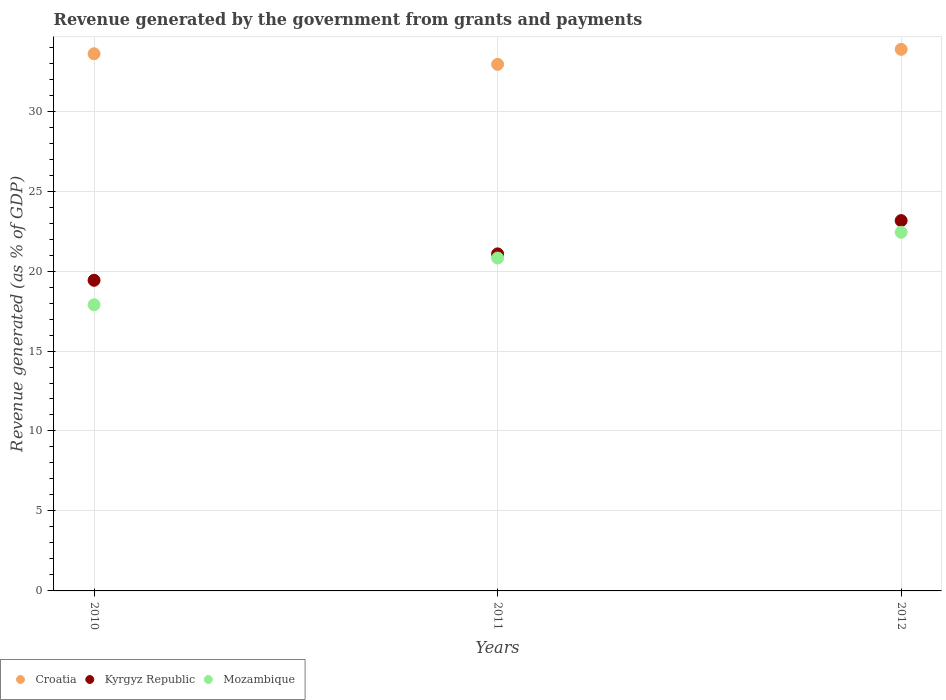How many different coloured dotlines are there?
Your answer should be compact. 3. What is the revenue generated by the government in Mozambique in 2010?
Make the answer very short. 17.89. Across all years, what is the maximum revenue generated by the government in Kyrgyz Republic?
Your answer should be very brief. 23.16. Across all years, what is the minimum revenue generated by the government in Croatia?
Your answer should be very brief. 32.92. In which year was the revenue generated by the government in Kyrgyz Republic minimum?
Make the answer very short. 2010. What is the total revenue generated by the government in Croatia in the graph?
Your answer should be compact. 100.37. What is the difference between the revenue generated by the government in Kyrgyz Republic in 2010 and that in 2012?
Your response must be concise. -3.73. What is the difference between the revenue generated by the government in Kyrgyz Republic in 2011 and the revenue generated by the government in Mozambique in 2012?
Provide a short and direct response. -1.35. What is the average revenue generated by the government in Mozambique per year?
Your answer should be very brief. 20.38. In the year 2012, what is the difference between the revenue generated by the government in Kyrgyz Republic and revenue generated by the government in Croatia?
Offer a terse response. -10.71. In how many years, is the revenue generated by the government in Mozambique greater than 15 %?
Make the answer very short. 3. What is the ratio of the revenue generated by the government in Croatia in 2010 to that in 2012?
Provide a short and direct response. 0.99. What is the difference between the highest and the second highest revenue generated by the government in Kyrgyz Republic?
Your response must be concise. 2.08. What is the difference between the highest and the lowest revenue generated by the government in Kyrgyz Republic?
Give a very brief answer. 3.73. Is it the case that in every year, the sum of the revenue generated by the government in Kyrgyz Republic and revenue generated by the government in Croatia  is greater than the revenue generated by the government in Mozambique?
Provide a succinct answer. Yes. Is the revenue generated by the government in Croatia strictly greater than the revenue generated by the government in Kyrgyz Republic over the years?
Offer a terse response. Yes. How many dotlines are there?
Your response must be concise. 3. How many years are there in the graph?
Your response must be concise. 3. What is the difference between two consecutive major ticks on the Y-axis?
Provide a succinct answer. 5. Are the values on the major ticks of Y-axis written in scientific E-notation?
Your answer should be very brief. No. Where does the legend appear in the graph?
Your response must be concise. Bottom left. How many legend labels are there?
Your answer should be very brief. 3. What is the title of the graph?
Provide a succinct answer. Revenue generated by the government from grants and payments. What is the label or title of the Y-axis?
Offer a terse response. Revenue generated (as % of GDP). What is the Revenue generated (as % of GDP) in Croatia in 2010?
Keep it short and to the point. 33.59. What is the Revenue generated (as % of GDP) of Kyrgyz Republic in 2010?
Provide a short and direct response. 19.42. What is the Revenue generated (as % of GDP) in Mozambique in 2010?
Keep it short and to the point. 17.89. What is the Revenue generated (as % of GDP) of Croatia in 2011?
Ensure brevity in your answer.  32.92. What is the Revenue generated (as % of GDP) in Kyrgyz Republic in 2011?
Offer a terse response. 21.07. What is the Revenue generated (as % of GDP) of Mozambique in 2011?
Make the answer very short. 20.81. What is the Revenue generated (as % of GDP) of Croatia in 2012?
Your answer should be very brief. 33.86. What is the Revenue generated (as % of GDP) of Kyrgyz Republic in 2012?
Provide a succinct answer. 23.16. What is the Revenue generated (as % of GDP) in Mozambique in 2012?
Make the answer very short. 22.42. Across all years, what is the maximum Revenue generated (as % of GDP) in Croatia?
Offer a terse response. 33.86. Across all years, what is the maximum Revenue generated (as % of GDP) of Kyrgyz Republic?
Your answer should be compact. 23.16. Across all years, what is the maximum Revenue generated (as % of GDP) in Mozambique?
Keep it short and to the point. 22.42. Across all years, what is the minimum Revenue generated (as % of GDP) of Croatia?
Provide a succinct answer. 32.92. Across all years, what is the minimum Revenue generated (as % of GDP) of Kyrgyz Republic?
Keep it short and to the point. 19.42. Across all years, what is the minimum Revenue generated (as % of GDP) in Mozambique?
Make the answer very short. 17.89. What is the total Revenue generated (as % of GDP) of Croatia in the graph?
Ensure brevity in your answer.  100.37. What is the total Revenue generated (as % of GDP) of Kyrgyz Republic in the graph?
Keep it short and to the point. 63.65. What is the total Revenue generated (as % of GDP) in Mozambique in the graph?
Your answer should be compact. 61.13. What is the difference between the Revenue generated (as % of GDP) in Croatia in 2010 and that in 2011?
Keep it short and to the point. 0.66. What is the difference between the Revenue generated (as % of GDP) in Kyrgyz Republic in 2010 and that in 2011?
Your response must be concise. -1.65. What is the difference between the Revenue generated (as % of GDP) in Mozambique in 2010 and that in 2011?
Your answer should be compact. -2.92. What is the difference between the Revenue generated (as % of GDP) of Croatia in 2010 and that in 2012?
Give a very brief answer. -0.28. What is the difference between the Revenue generated (as % of GDP) in Kyrgyz Republic in 2010 and that in 2012?
Your answer should be compact. -3.73. What is the difference between the Revenue generated (as % of GDP) of Mozambique in 2010 and that in 2012?
Offer a very short reply. -4.53. What is the difference between the Revenue generated (as % of GDP) in Croatia in 2011 and that in 2012?
Your answer should be compact. -0.94. What is the difference between the Revenue generated (as % of GDP) of Kyrgyz Republic in 2011 and that in 2012?
Offer a very short reply. -2.08. What is the difference between the Revenue generated (as % of GDP) of Mozambique in 2011 and that in 2012?
Ensure brevity in your answer.  -1.61. What is the difference between the Revenue generated (as % of GDP) in Croatia in 2010 and the Revenue generated (as % of GDP) in Kyrgyz Republic in 2011?
Your answer should be very brief. 12.51. What is the difference between the Revenue generated (as % of GDP) in Croatia in 2010 and the Revenue generated (as % of GDP) in Mozambique in 2011?
Offer a very short reply. 12.77. What is the difference between the Revenue generated (as % of GDP) of Kyrgyz Republic in 2010 and the Revenue generated (as % of GDP) of Mozambique in 2011?
Provide a short and direct response. -1.39. What is the difference between the Revenue generated (as % of GDP) of Croatia in 2010 and the Revenue generated (as % of GDP) of Kyrgyz Republic in 2012?
Keep it short and to the point. 10.43. What is the difference between the Revenue generated (as % of GDP) of Croatia in 2010 and the Revenue generated (as % of GDP) of Mozambique in 2012?
Ensure brevity in your answer.  11.16. What is the difference between the Revenue generated (as % of GDP) in Kyrgyz Republic in 2010 and the Revenue generated (as % of GDP) in Mozambique in 2012?
Give a very brief answer. -3. What is the difference between the Revenue generated (as % of GDP) of Croatia in 2011 and the Revenue generated (as % of GDP) of Kyrgyz Republic in 2012?
Offer a very short reply. 9.77. What is the difference between the Revenue generated (as % of GDP) of Croatia in 2011 and the Revenue generated (as % of GDP) of Mozambique in 2012?
Offer a terse response. 10.5. What is the difference between the Revenue generated (as % of GDP) in Kyrgyz Republic in 2011 and the Revenue generated (as % of GDP) in Mozambique in 2012?
Give a very brief answer. -1.35. What is the average Revenue generated (as % of GDP) in Croatia per year?
Give a very brief answer. 33.46. What is the average Revenue generated (as % of GDP) of Kyrgyz Republic per year?
Offer a terse response. 21.22. What is the average Revenue generated (as % of GDP) in Mozambique per year?
Give a very brief answer. 20.38. In the year 2010, what is the difference between the Revenue generated (as % of GDP) of Croatia and Revenue generated (as % of GDP) of Kyrgyz Republic?
Give a very brief answer. 14.16. In the year 2010, what is the difference between the Revenue generated (as % of GDP) of Croatia and Revenue generated (as % of GDP) of Mozambique?
Your response must be concise. 15.69. In the year 2010, what is the difference between the Revenue generated (as % of GDP) in Kyrgyz Republic and Revenue generated (as % of GDP) in Mozambique?
Ensure brevity in your answer.  1.53. In the year 2011, what is the difference between the Revenue generated (as % of GDP) of Croatia and Revenue generated (as % of GDP) of Kyrgyz Republic?
Offer a terse response. 11.85. In the year 2011, what is the difference between the Revenue generated (as % of GDP) in Croatia and Revenue generated (as % of GDP) in Mozambique?
Provide a succinct answer. 12.11. In the year 2011, what is the difference between the Revenue generated (as % of GDP) of Kyrgyz Republic and Revenue generated (as % of GDP) of Mozambique?
Ensure brevity in your answer.  0.26. In the year 2012, what is the difference between the Revenue generated (as % of GDP) of Croatia and Revenue generated (as % of GDP) of Kyrgyz Republic?
Keep it short and to the point. 10.71. In the year 2012, what is the difference between the Revenue generated (as % of GDP) in Croatia and Revenue generated (as % of GDP) in Mozambique?
Your answer should be compact. 11.44. In the year 2012, what is the difference between the Revenue generated (as % of GDP) of Kyrgyz Republic and Revenue generated (as % of GDP) of Mozambique?
Your answer should be very brief. 0.73. What is the ratio of the Revenue generated (as % of GDP) in Croatia in 2010 to that in 2011?
Your response must be concise. 1.02. What is the ratio of the Revenue generated (as % of GDP) in Kyrgyz Republic in 2010 to that in 2011?
Your answer should be very brief. 0.92. What is the ratio of the Revenue generated (as % of GDP) in Mozambique in 2010 to that in 2011?
Make the answer very short. 0.86. What is the ratio of the Revenue generated (as % of GDP) in Croatia in 2010 to that in 2012?
Your response must be concise. 0.99. What is the ratio of the Revenue generated (as % of GDP) in Kyrgyz Republic in 2010 to that in 2012?
Keep it short and to the point. 0.84. What is the ratio of the Revenue generated (as % of GDP) in Mozambique in 2010 to that in 2012?
Your answer should be compact. 0.8. What is the ratio of the Revenue generated (as % of GDP) of Croatia in 2011 to that in 2012?
Your answer should be very brief. 0.97. What is the ratio of the Revenue generated (as % of GDP) of Kyrgyz Republic in 2011 to that in 2012?
Your answer should be very brief. 0.91. What is the ratio of the Revenue generated (as % of GDP) of Mozambique in 2011 to that in 2012?
Provide a short and direct response. 0.93. What is the difference between the highest and the second highest Revenue generated (as % of GDP) of Croatia?
Your response must be concise. 0.28. What is the difference between the highest and the second highest Revenue generated (as % of GDP) in Kyrgyz Republic?
Offer a very short reply. 2.08. What is the difference between the highest and the second highest Revenue generated (as % of GDP) in Mozambique?
Your answer should be compact. 1.61. What is the difference between the highest and the lowest Revenue generated (as % of GDP) of Croatia?
Provide a short and direct response. 0.94. What is the difference between the highest and the lowest Revenue generated (as % of GDP) of Kyrgyz Republic?
Your answer should be very brief. 3.73. What is the difference between the highest and the lowest Revenue generated (as % of GDP) of Mozambique?
Provide a short and direct response. 4.53. 